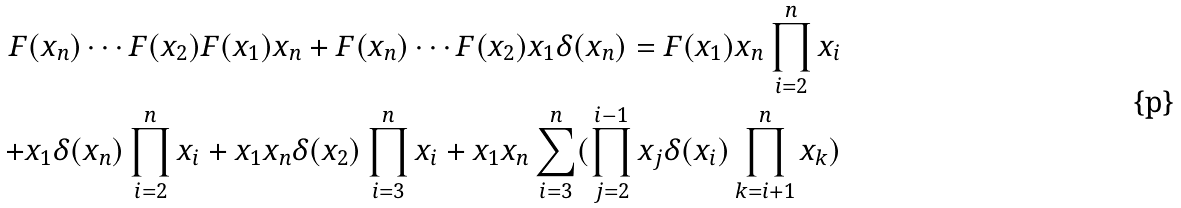<formula> <loc_0><loc_0><loc_500><loc_500>F ( x _ { n } ) \cdots F ( x _ { 2 } ) F ( x _ { 1 } ) x _ { n } + F ( x _ { n } ) \cdots F ( x _ { 2 } ) x _ { 1 } \delta ( x _ { n } ) = F ( x _ { 1 } ) x _ { n } \prod _ { i = 2 } ^ { n } x _ { i } \\ + x _ { 1 } \delta ( x _ { n } ) \prod _ { i = 2 } ^ { n } x _ { i } + x _ { 1 } x _ { n } \delta ( x _ { 2 } ) \prod _ { i = 3 } ^ { n } x _ { i } + x _ { 1 } x _ { n } \sum _ { i = 3 } ^ { n } ( \prod _ { j = 2 } ^ { i - 1 } x _ { j } \delta ( x _ { i } ) \prod _ { k = i + 1 } ^ { n } x _ { k } )</formula> 